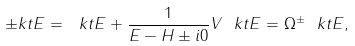<formula> <loc_0><loc_0><loc_500><loc_500>\pm k t { E } = \ k t { E } + \frac { 1 } { E - H \pm i 0 } V \ k t { E } = \Omega ^ { \pm } \ k t { E } ,</formula> 